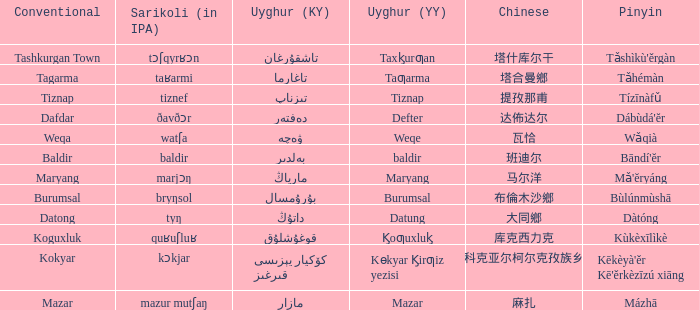Name the pinyin for تىزناپ Tízīnàfǔ. 